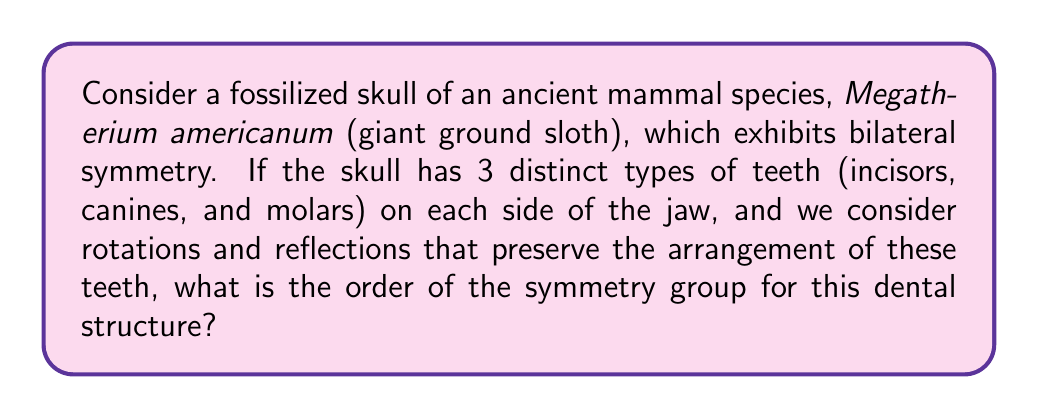Solve this math problem. To solve this problem, we need to consider the symmetries of the dental structure:

1. Bilateral symmetry: The skull has a plane of reflection that divides it into left and right halves.

2. Tooth arrangement: There are 3 distinct types of teeth on each side of the jaw.

3. Possible symmetries:
   a. Identity transformation (leaving the structure unchanged)
   b. Reflection across the bilateral plane
   c. Rotation by 180 degrees (equivalent to applying the reflection twice)

The symmetry group of this structure is isomorphic to the cyclic group of order 2, $C_2$, or the dihedral group $D_1$.

To determine the order of the symmetry group, we count the number of distinct symmetry operations:

1. Identity: 1 operation
2. Reflection: 1 operation
3. Rotation by 180 degrees: This is equivalent to applying the reflection twice, so it's not a distinct operation.

Therefore, the total number of distinct symmetry operations is 1 + 1 = 2.

In group theory, the order of a group is the number of elements in the group. In this case, the order of the symmetry group is 2.

This result is consistent with the structure of $C_2$ and $D_1$, both of which have order 2.
Answer: The order of the symmetry group for the dental structure of the Megatherium americanum skull is 2. 